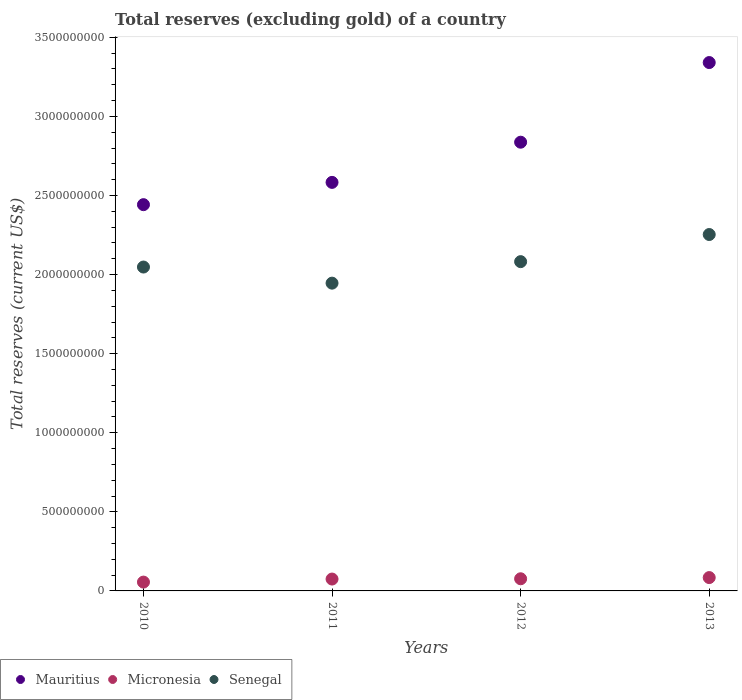How many different coloured dotlines are there?
Your answer should be very brief. 3. What is the total reserves (excluding gold) in Senegal in 2012?
Ensure brevity in your answer.  2.08e+09. Across all years, what is the maximum total reserves (excluding gold) in Mauritius?
Provide a succinct answer. 3.34e+09. Across all years, what is the minimum total reserves (excluding gold) in Micronesia?
Give a very brief answer. 5.58e+07. In which year was the total reserves (excluding gold) in Mauritius minimum?
Provide a short and direct response. 2010. What is the total total reserves (excluding gold) in Senegal in the graph?
Give a very brief answer. 8.33e+09. What is the difference between the total reserves (excluding gold) in Mauritius in 2010 and that in 2012?
Provide a succinct answer. -3.95e+08. What is the difference between the total reserves (excluding gold) in Senegal in 2011 and the total reserves (excluding gold) in Mauritius in 2012?
Offer a very short reply. -8.91e+08. What is the average total reserves (excluding gold) in Senegal per year?
Your response must be concise. 2.08e+09. In the year 2012, what is the difference between the total reserves (excluding gold) in Micronesia and total reserves (excluding gold) in Senegal?
Ensure brevity in your answer.  -2.00e+09. In how many years, is the total reserves (excluding gold) in Micronesia greater than 2000000000 US$?
Your answer should be compact. 0. What is the ratio of the total reserves (excluding gold) in Micronesia in 2010 to that in 2013?
Give a very brief answer. 0.66. What is the difference between the highest and the second highest total reserves (excluding gold) in Mauritius?
Keep it short and to the point. 5.04e+08. What is the difference between the highest and the lowest total reserves (excluding gold) in Micronesia?
Provide a short and direct response. 2.86e+07. In how many years, is the total reserves (excluding gold) in Mauritius greater than the average total reserves (excluding gold) in Mauritius taken over all years?
Give a very brief answer. 2. Is the total reserves (excluding gold) in Mauritius strictly greater than the total reserves (excluding gold) in Micronesia over the years?
Your answer should be compact. Yes. Are the values on the major ticks of Y-axis written in scientific E-notation?
Your answer should be very brief. No. Does the graph contain any zero values?
Make the answer very short. No. Does the graph contain grids?
Keep it short and to the point. No. Where does the legend appear in the graph?
Provide a short and direct response. Bottom left. How are the legend labels stacked?
Offer a very short reply. Horizontal. What is the title of the graph?
Provide a short and direct response. Total reserves (excluding gold) of a country. What is the label or title of the Y-axis?
Provide a succinct answer. Total reserves (current US$). What is the Total reserves (current US$) in Mauritius in 2010?
Make the answer very short. 2.44e+09. What is the Total reserves (current US$) of Micronesia in 2010?
Provide a succinct answer. 5.58e+07. What is the Total reserves (current US$) in Senegal in 2010?
Offer a terse response. 2.05e+09. What is the Total reserves (current US$) in Mauritius in 2011?
Keep it short and to the point. 2.58e+09. What is the Total reserves (current US$) of Micronesia in 2011?
Your answer should be very brief. 7.51e+07. What is the Total reserves (current US$) in Senegal in 2011?
Give a very brief answer. 1.95e+09. What is the Total reserves (current US$) in Mauritius in 2012?
Offer a terse response. 2.84e+09. What is the Total reserves (current US$) of Micronesia in 2012?
Ensure brevity in your answer.  7.68e+07. What is the Total reserves (current US$) of Senegal in 2012?
Your answer should be very brief. 2.08e+09. What is the Total reserves (current US$) of Mauritius in 2013?
Your response must be concise. 3.34e+09. What is the Total reserves (current US$) of Micronesia in 2013?
Ensure brevity in your answer.  8.43e+07. What is the Total reserves (current US$) of Senegal in 2013?
Your answer should be very brief. 2.25e+09. Across all years, what is the maximum Total reserves (current US$) in Mauritius?
Provide a short and direct response. 3.34e+09. Across all years, what is the maximum Total reserves (current US$) of Micronesia?
Offer a terse response. 8.43e+07. Across all years, what is the maximum Total reserves (current US$) of Senegal?
Your answer should be compact. 2.25e+09. Across all years, what is the minimum Total reserves (current US$) in Mauritius?
Ensure brevity in your answer.  2.44e+09. Across all years, what is the minimum Total reserves (current US$) in Micronesia?
Give a very brief answer. 5.58e+07. Across all years, what is the minimum Total reserves (current US$) of Senegal?
Keep it short and to the point. 1.95e+09. What is the total Total reserves (current US$) of Mauritius in the graph?
Ensure brevity in your answer.  1.12e+1. What is the total Total reserves (current US$) in Micronesia in the graph?
Make the answer very short. 2.92e+08. What is the total Total reserves (current US$) of Senegal in the graph?
Make the answer very short. 8.33e+09. What is the difference between the Total reserves (current US$) of Mauritius in 2010 and that in 2011?
Give a very brief answer. -1.41e+08. What is the difference between the Total reserves (current US$) in Micronesia in 2010 and that in 2011?
Make the answer very short. -1.93e+07. What is the difference between the Total reserves (current US$) of Senegal in 2010 and that in 2011?
Provide a short and direct response. 1.02e+08. What is the difference between the Total reserves (current US$) of Mauritius in 2010 and that in 2012?
Keep it short and to the point. -3.95e+08. What is the difference between the Total reserves (current US$) in Micronesia in 2010 and that in 2012?
Offer a very short reply. -2.10e+07. What is the difference between the Total reserves (current US$) in Senegal in 2010 and that in 2012?
Your answer should be very brief. -3.41e+07. What is the difference between the Total reserves (current US$) in Mauritius in 2010 and that in 2013?
Give a very brief answer. -8.98e+08. What is the difference between the Total reserves (current US$) of Micronesia in 2010 and that in 2013?
Provide a succinct answer. -2.86e+07. What is the difference between the Total reserves (current US$) of Senegal in 2010 and that in 2013?
Your response must be concise. -2.06e+08. What is the difference between the Total reserves (current US$) of Mauritius in 2011 and that in 2012?
Provide a succinct answer. -2.54e+08. What is the difference between the Total reserves (current US$) of Micronesia in 2011 and that in 2012?
Keep it short and to the point. -1.73e+06. What is the difference between the Total reserves (current US$) in Senegal in 2011 and that in 2012?
Your answer should be compact. -1.36e+08. What is the difference between the Total reserves (current US$) of Mauritius in 2011 and that in 2013?
Ensure brevity in your answer.  -7.58e+08. What is the difference between the Total reserves (current US$) in Micronesia in 2011 and that in 2013?
Keep it short and to the point. -9.28e+06. What is the difference between the Total reserves (current US$) in Senegal in 2011 and that in 2013?
Provide a short and direct response. -3.07e+08. What is the difference between the Total reserves (current US$) of Mauritius in 2012 and that in 2013?
Ensure brevity in your answer.  -5.04e+08. What is the difference between the Total reserves (current US$) in Micronesia in 2012 and that in 2013?
Give a very brief answer. -7.55e+06. What is the difference between the Total reserves (current US$) in Senegal in 2012 and that in 2013?
Provide a short and direct response. -1.71e+08. What is the difference between the Total reserves (current US$) of Mauritius in 2010 and the Total reserves (current US$) of Micronesia in 2011?
Make the answer very short. 2.37e+09. What is the difference between the Total reserves (current US$) in Mauritius in 2010 and the Total reserves (current US$) in Senegal in 2011?
Give a very brief answer. 4.96e+08. What is the difference between the Total reserves (current US$) in Micronesia in 2010 and the Total reserves (current US$) in Senegal in 2011?
Your answer should be very brief. -1.89e+09. What is the difference between the Total reserves (current US$) in Mauritius in 2010 and the Total reserves (current US$) in Micronesia in 2012?
Give a very brief answer. 2.37e+09. What is the difference between the Total reserves (current US$) of Mauritius in 2010 and the Total reserves (current US$) of Senegal in 2012?
Offer a very short reply. 3.60e+08. What is the difference between the Total reserves (current US$) of Micronesia in 2010 and the Total reserves (current US$) of Senegal in 2012?
Your answer should be very brief. -2.03e+09. What is the difference between the Total reserves (current US$) in Mauritius in 2010 and the Total reserves (current US$) in Micronesia in 2013?
Your answer should be very brief. 2.36e+09. What is the difference between the Total reserves (current US$) of Mauritius in 2010 and the Total reserves (current US$) of Senegal in 2013?
Provide a short and direct response. 1.89e+08. What is the difference between the Total reserves (current US$) of Micronesia in 2010 and the Total reserves (current US$) of Senegal in 2013?
Offer a terse response. -2.20e+09. What is the difference between the Total reserves (current US$) in Mauritius in 2011 and the Total reserves (current US$) in Micronesia in 2012?
Your response must be concise. 2.51e+09. What is the difference between the Total reserves (current US$) in Mauritius in 2011 and the Total reserves (current US$) in Senegal in 2012?
Make the answer very short. 5.01e+08. What is the difference between the Total reserves (current US$) of Micronesia in 2011 and the Total reserves (current US$) of Senegal in 2012?
Offer a very short reply. -2.01e+09. What is the difference between the Total reserves (current US$) in Mauritius in 2011 and the Total reserves (current US$) in Micronesia in 2013?
Your response must be concise. 2.50e+09. What is the difference between the Total reserves (current US$) of Mauritius in 2011 and the Total reserves (current US$) of Senegal in 2013?
Your response must be concise. 3.30e+08. What is the difference between the Total reserves (current US$) in Micronesia in 2011 and the Total reserves (current US$) in Senegal in 2013?
Make the answer very short. -2.18e+09. What is the difference between the Total reserves (current US$) of Mauritius in 2012 and the Total reserves (current US$) of Micronesia in 2013?
Ensure brevity in your answer.  2.75e+09. What is the difference between the Total reserves (current US$) in Mauritius in 2012 and the Total reserves (current US$) in Senegal in 2013?
Offer a terse response. 5.84e+08. What is the difference between the Total reserves (current US$) in Micronesia in 2012 and the Total reserves (current US$) in Senegal in 2013?
Provide a short and direct response. -2.18e+09. What is the average Total reserves (current US$) of Mauritius per year?
Provide a succinct answer. 2.80e+09. What is the average Total reserves (current US$) in Micronesia per year?
Your response must be concise. 7.30e+07. What is the average Total reserves (current US$) in Senegal per year?
Keep it short and to the point. 2.08e+09. In the year 2010, what is the difference between the Total reserves (current US$) of Mauritius and Total reserves (current US$) of Micronesia?
Your answer should be compact. 2.39e+09. In the year 2010, what is the difference between the Total reserves (current US$) in Mauritius and Total reserves (current US$) in Senegal?
Ensure brevity in your answer.  3.94e+08. In the year 2010, what is the difference between the Total reserves (current US$) in Micronesia and Total reserves (current US$) in Senegal?
Offer a terse response. -1.99e+09. In the year 2011, what is the difference between the Total reserves (current US$) in Mauritius and Total reserves (current US$) in Micronesia?
Give a very brief answer. 2.51e+09. In the year 2011, what is the difference between the Total reserves (current US$) in Mauritius and Total reserves (current US$) in Senegal?
Your answer should be compact. 6.37e+08. In the year 2011, what is the difference between the Total reserves (current US$) of Micronesia and Total reserves (current US$) of Senegal?
Ensure brevity in your answer.  -1.87e+09. In the year 2012, what is the difference between the Total reserves (current US$) of Mauritius and Total reserves (current US$) of Micronesia?
Offer a very short reply. 2.76e+09. In the year 2012, what is the difference between the Total reserves (current US$) of Mauritius and Total reserves (current US$) of Senegal?
Ensure brevity in your answer.  7.55e+08. In the year 2012, what is the difference between the Total reserves (current US$) of Micronesia and Total reserves (current US$) of Senegal?
Provide a short and direct response. -2.00e+09. In the year 2013, what is the difference between the Total reserves (current US$) in Mauritius and Total reserves (current US$) in Micronesia?
Give a very brief answer. 3.26e+09. In the year 2013, what is the difference between the Total reserves (current US$) in Mauritius and Total reserves (current US$) in Senegal?
Offer a terse response. 1.09e+09. In the year 2013, what is the difference between the Total reserves (current US$) of Micronesia and Total reserves (current US$) of Senegal?
Ensure brevity in your answer.  -2.17e+09. What is the ratio of the Total reserves (current US$) of Mauritius in 2010 to that in 2011?
Give a very brief answer. 0.95. What is the ratio of the Total reserves (current US$) in Micronesia in 2010 to that in 2011?
Your answer should be compact. 0.74. What is the ratio of the Total reserves (current US$) in Senegal in 2010 to that in 2011?
Offer a terse response. 1.05. What is the ratio of the Total reserves (current US$) in Mauritius in 2010 to that in 2012?
Keep it short and to the point. 0.86. What is the ratio of the Total reserves (current US$) in Micronesia in 2010 to that in 2012?
Give a very brief answer. 0.73. What is the ratio of the Total reserves (current US$) in Senegal in 2010 to that in 2012?
Offer a very short reply. 0.98. What is the ratio of the Total reserves (current US$) in Mauritius in 2010 to that in 2013?
Your response must be concise. 0.73. What is the ratio of the Total reserves (current US$) in Micronesia in 2010 to that in 2013?
Your response must be concise. 0.66. What is the ratio of the Total reserves (current US$) in Senegal in 2010 to that in 2013?
Provide a succinct answer. 0.91. What is the ratio of the Total reserves (current US$) of Mauritius in 2011 to that in 2012?
Give a very brief answer. 0.91. What is the ratio of the Total reserves (current US$) in Micronesia in 2011 to that in 2012?
Offer a very short reply. 0.98. What is the ratio of the Total reserves (current US$) in Senegal in 2011 to that in 2012?
Your answer should be compact. 0.93. What is the ratio of the Total reserves (current US$) in Mauritius in 2011 to that in 2013?
Your answer should be compact. 0.77. What is the ratio of the Total reserves (current US$) in Micronesia in 2011 to that in 2013?
Provide a succinct answer. 0.89. What is the ratio of the Total reserves (current US$) in Senegal in 2011 to that in 2013?
Keep it short and to the point. 0.86. What is the ratio of the Total reserves (current US$) in Mauritius in 2012 to that in 2013?
Your response must be concise. 0.85. What is the ratio of the Total reserves (current US$) in Micronesia in 2012 to that in 2013?
Keep it short and to the point. 0.91. What is the ratio of the Total reserves (current US$) in Senegal in 2012 to that in 2013?
Offer a terse response. 0.92. What is the difference between the highest and the second highest Total reserves (current US$) in Mauritius?
Your answer should be compact. 5.04e+08. What is the difference between the highest and the second highest Total reserves (current US$) in Micronesia?
Make the answer very short. 7.55e+06. What is the difference between the highest and the second highest Total reserves (current US$) of Senegal?
Your answer should be very brief. 1.71e+08. What is the difference between the highest and the lowest Total reserves (current US$) in Mauritius?
Ensure brevity in your answer.  8.98e+08. What is the difference between the highest and the lowest Total reserves (current US$) in Micronesia?
Give a very brief answer. 2.86e+07. What is the difference between the highest and the lowest Total reserves (current US$) in Senegal?
Give a very brief answer. 3.07e+08. 